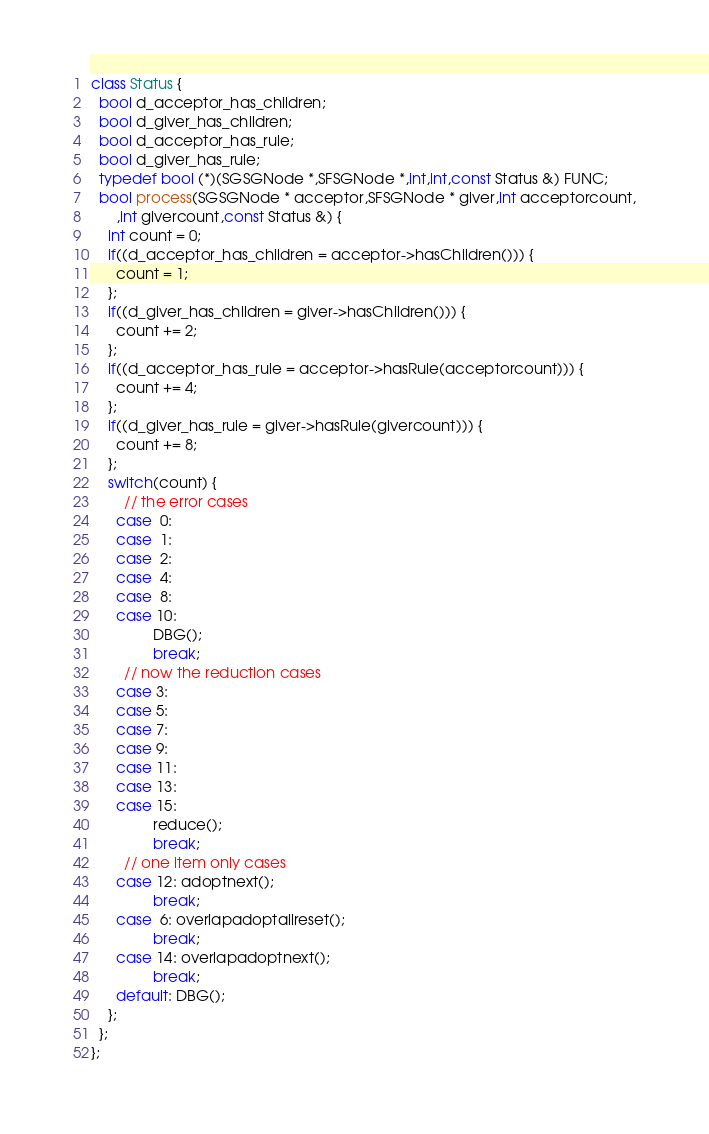<code> <loc_0><loc_0><loc_500><loc_500><_C++_>class Status {
  bool d_acceptor_has_children;
  bool d_giver_has_children;
  bool d_acceptor_has_rule;
  bool d_giver_has_rule;
  typedef bool (*)(SGSGNode *,SFSGNode *,int,int,const Status &) FUNC;
  bool process(SGSGNode * acceptor,SFSGNode * giver,int acceptorcount,
      ,int givercount,const Status &) {
    int count = 0;
    if((d_acceptor_has_children = acceptor->hasChildren())) {
      count = 1;
    };
    if((d_giver_has_children = giver->hasChildren())) {
      count += 2;
    };
    if((d_acceptor_has_rule = acceptor->hasRule(acceptorcount))) {
      count += 4;
    };
    if((d_giver_has_rule = giver->hasRule(givercount))) {
      count += 8;
    };
    switch(count) {
        // the error cases
      case  0:
      case  1:
      case  2:
      case  4: 
      case  8: 
      case 10: 
               DBG();
               break;
        // now the reduction cases 
      case 3:
      case 5:
      case 7:
      case 9:
      case 11:
      case 13:
      case 15:
               reduce();
               break;
        // one item only cases
      case 12: adoptnext();
               break;
      case  6: overlapadoptallreset();
               break;
      case 14: overlapadoptnext();     
               break;
      default: DBG();
    };
  };
};
</code> 